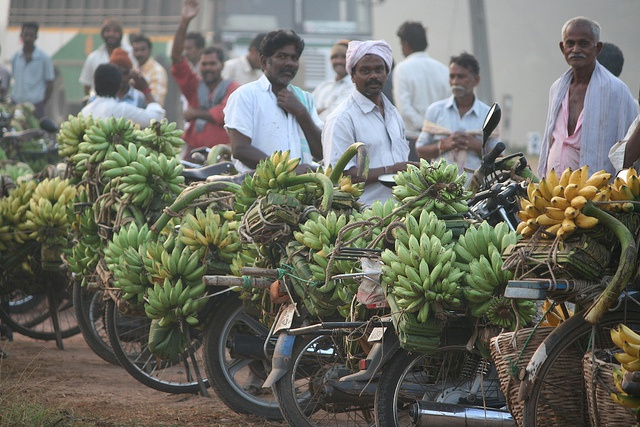Describe the objects in this image and their specific colors. I can see banana in lightgray, gray, darkgreen, black, and olive tones, bus in lightgray, darkgray, and gray tones, motorcycle in lightgray, black, gray, and darkgray tones, motorcycle in lightgray, black, and gray tones, and bicycle in lightgray, black, gray, and darkgray tones in this image. 